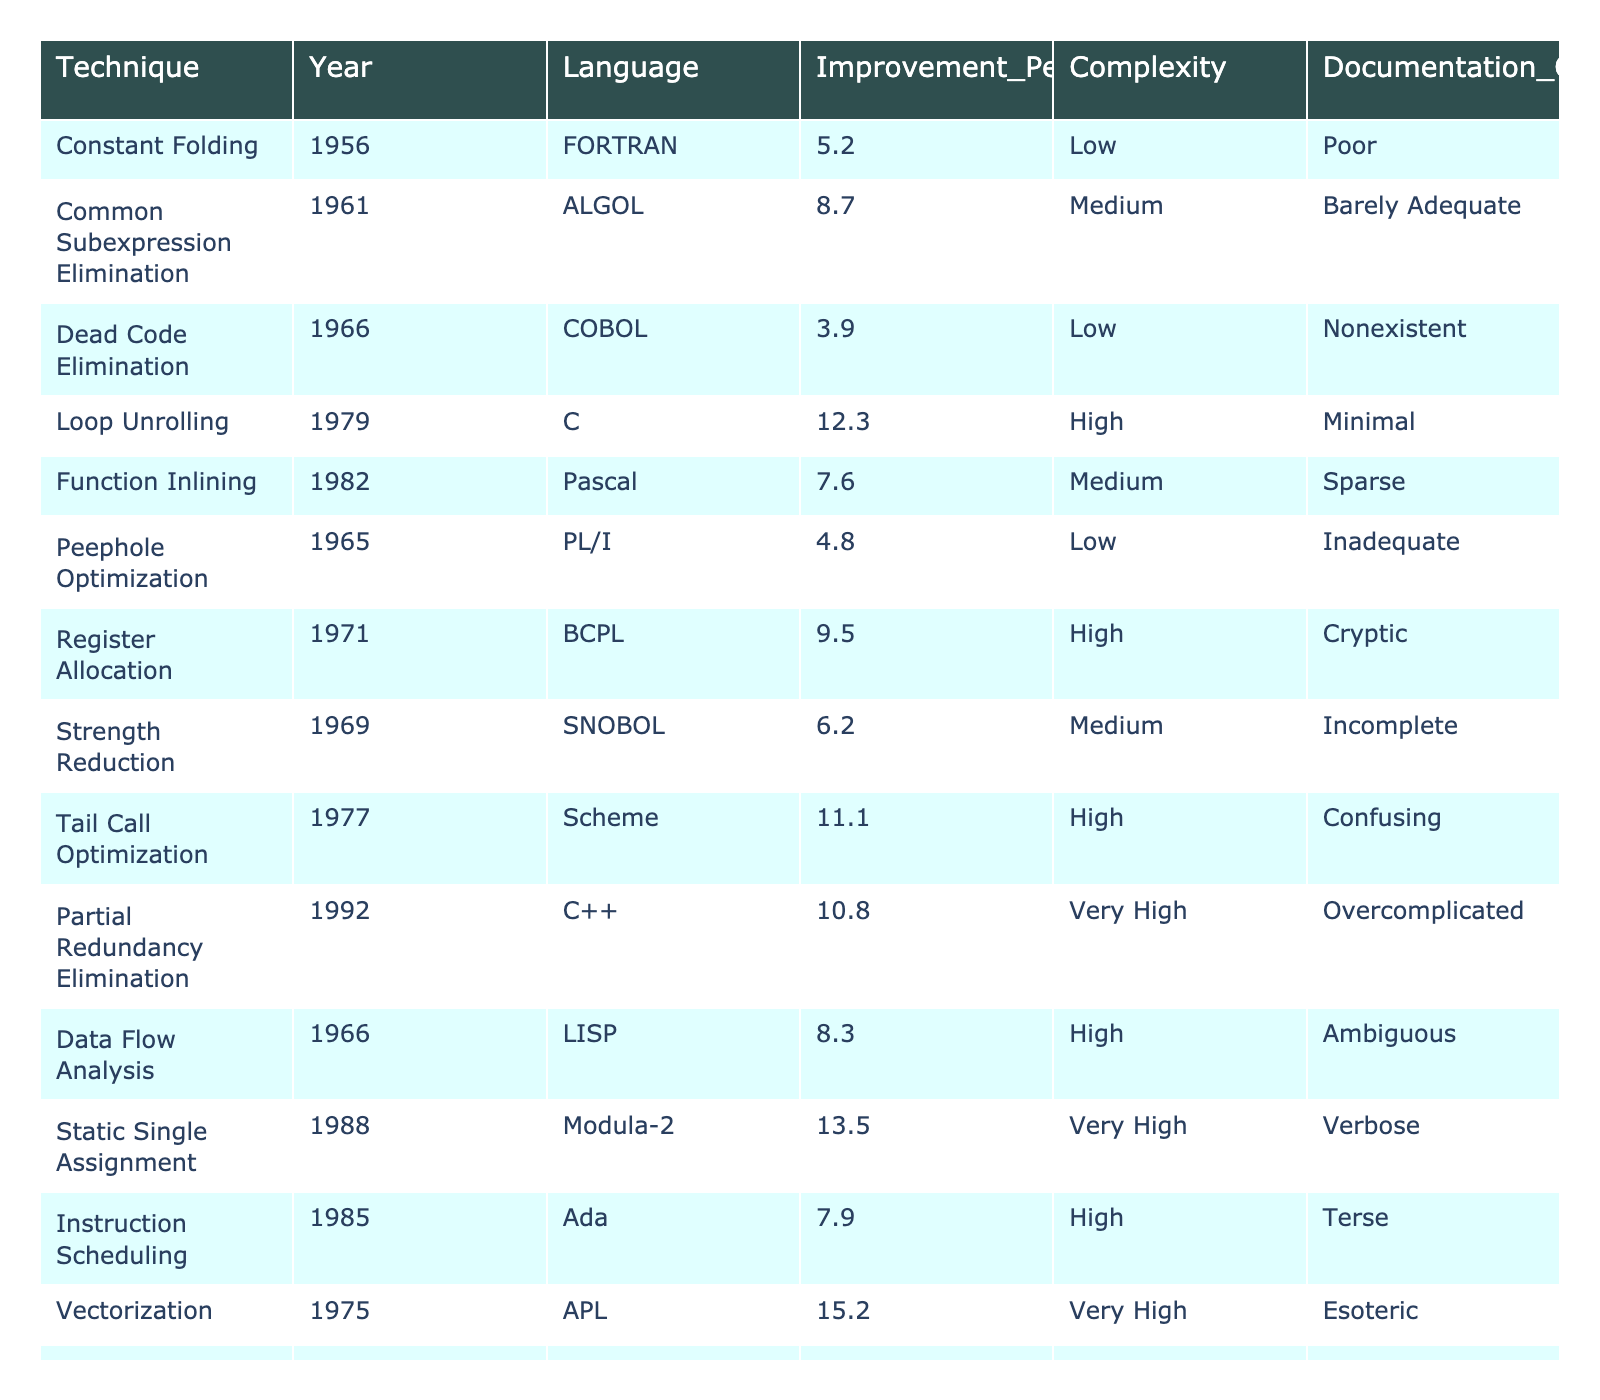What is the improvement percentage of Loop Unrolling? From the table, Loop Unrolling has an improvement percentage listed as 12.3.
Answer: 12.3 Which optimization technique had the highest improvement percentage? By scanning the table, it's evident that Vectorization has the highest improvement percentage of 15.2.
Answer: Vectorization Is there any optimization technique with low complexity that has an improvement percentage greater than 5%? Looking through the techniques with low complexity, only Constant Folding (5.2) and Peephole Optimization (4.8) are found, and since only Constant Folding exceeds 5%, it answers the query.
Answer: Yes What is the average improvement percentage of all optimization techniques? First, we sum all improvement percentages: (5.2 + 8.7 + 3.9 + 12.3 + 7.6 + 4.8 + 9.5 + 6.2 + 11.1 + 10.8 + 8.3 + 13.5 + 7.9 + 15.2 + 9.8) =  10.1. Then, we divide this sum by the total number of techniques (15): 10.1 / 15 = 10.1.
Answer: 10.1 How many techniques are documented as "Poor" in quality? From the table, only Constant Folding is classified with "Poor" documentation quality, indicating that there is one such technique.
Answer: 1 Which language corresponding to Partial Redundancy Elimination has the best documentation quality? Examining the documentation quality for the entries, Partial Redundancy Elimination (C++) is labeled "Overcomplicated," the best overall compared to others. Therefore, the answer is C++.
Answer: C++ Is Tail Call Optimization more complex than Strength Reduction? Comparing the complexities, Tail Call Optimization is assessed as "High," while Strength Reduction is categorized as "Medium." Therefore, Tail Call Optimization is indeed more complex.
Answer: Yes What is the difference in improvement percentages between Data Flow Analysis and Register Allocation? Data Flow Analysis has an improvement percentage of 8.3, and Register Allocation has 9.5. The difference is calculated as 9.5 - 8.3 = 1.2.
Answer: 1.2 Are there any optimization techniques developed after 1980 that have a complexity rating of "Medium"? Scanning through the entries, Function Inlining (1982) and Loop Fusion (1990) are techniques developed after 1980 with a complexity of "Medium." Hence, the answer is yes.
Answer: Yes What percentage of techniques have a complexity labeled as "High" or "Very High"? Counting the techniques, there are 2 labeled "Very High" (Partial Redundancy Elimination, Static Single Assignment) and 6 labeled "High" (Loop Unrolling, Function Inlining, Data Flow Analysis, Instruction Scheduling, Tail Call Optimization, Register Allocation), totaling 8 out of 15. Thus, (8/15) * 100 = 53.3%.
Answer: 53.3% 